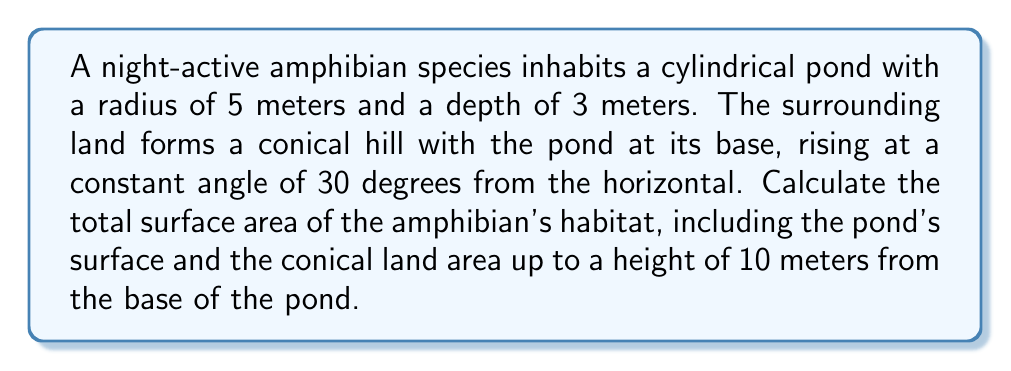What is the answer to this math problem? Let's break this down step-by-step:

1) First, we need to calculate the surface area of the pond:
   The pond surface is a circle with radius 5 meters.
   Area of pond surface = $\pi r^2 = \pi \cdot 5^2 = 25\pi$ m²

2) Next, we need to calculate the surface area of the conical land:
   We can visualize this as a truncated cone (frustum).

3) To calculate the surface area of the frustum, we need its slant height and the radius of its top circle.

4) The height of the frustum is 10 meters (given in the question).

5) To find the radius of the top circle, we use trigonometry:
   $\tan 30° = \frac{\text{opposite}}{\text{adjacent}} = \frac{10}{x}$, where x is the horizontal distance.
   $x = \frac{10}{\tan 30°} = 10 \cdot \sqrt{3} \approx 17.32$ meters

6) The radius of the top circle is therefore:
   $5 + 17.32 = 22.32$ meters

7) Now we can calculate the slant height (s) using the Pythagorean theorem:
   $s^2 = 10^2 + 17.32^2$
   $s = \sqrt{400} = 20$ meters

8) The surface area of a frustum is given by the formula:
   $SA = \pi(r_1 + r_2)s$
   Where $r_1$ and $r_2$ are the radii of the base and top circles, and s is the slant height.

9) Plugging in our values:
   $SA = \pi(5 + 22.32) \cdot 20 = 1721.6\pi$ m²

10) The total surface area is the sum of the pond surface and the conical land surface:
    Total SA = $25\pi + 1721.6\pi = 1746.6\pi$ m²
Answer: $1746.6\pi$ m² 